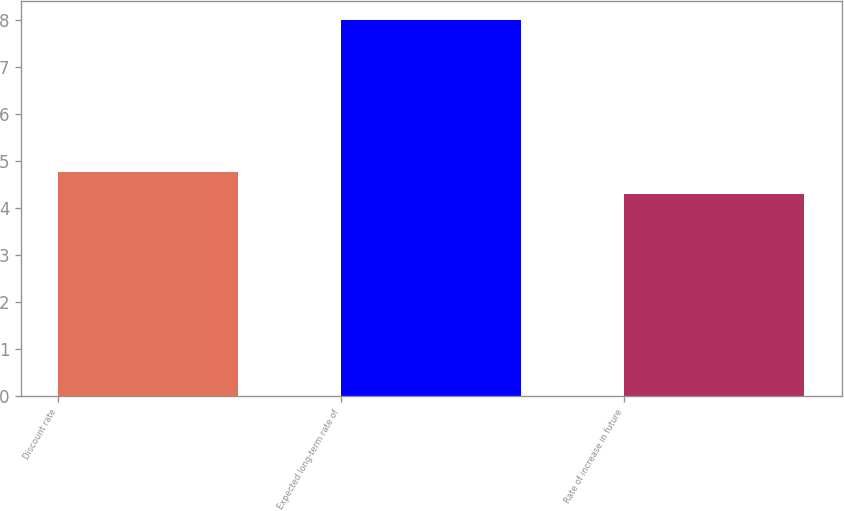Convert chart. <chart><loc_0><loc_0><loc_500><loc_500><bar_chart><fcel>Discount rate<fcel>Expected long-term rate of<fcel>Rate of increase in future<nl><fcel>4.75<fcel>8<fcel>4.3<nl></chart> 